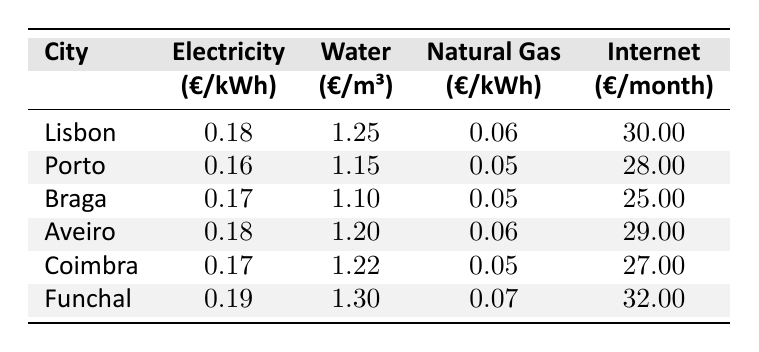What is the electricity price in Porto? The table shows that the electricity price in Porto is listed as 0.16 €/kWh.
Answer: 0.16 €/kWh Which city has the highest water price? By examining the water prices, Funchal has the highest water price at 1.30 €/m³.
Answer: Funchal What is the average natural gas price across all cities? Adding the natural gas prices: (0.06 + 0.05 + 0.05 + 0.06 + 0.05 + 0.07) = 0.34, then dividing by 6 gives an average of 0.34 / 6 ≈ 0.057.
Answer: 0.057 €/kWh Is the monthly internet price in Braga lower than in Coimbra? The table indicates that Braga's internet price is 25.00 €, while Coimbra's is 27.00 €, making Braga's price lower.
Answer: Yes Which city has the lowest internet price? The table shows that Braga has the lowest internet price at 25.00 €.
Answer: Braga How much more expensive is water in Funchal compared to Porto? The water price in Funchal is 1.30 €/m³ and in Porto, it is 1.15 €/m³. The difference is 1.30 - 1.15 = 0.15.
Answer: 0.15 €/m³ What city has the second lowest price for electricity? The list of electricity prices shows that Braga's price of 0.17 €/kWh is the second lowest after Porto.
Answer: Braga If you average the electricity prices in Lisbon and Aveiro, what is the result? The electricity prices in Lisbon (0.18) and Aveiro (0.18) together sum to 0.36 and dividing by 2 yields an average of 0.36 / 2 = 0.18.
Answer: 0.18 €/kWh Are the internet prices in Lisbon and Aveiro the same? The internet price in Lisbon is 30.00 €, while in Aveiro it is 29.00 €, so they are not the same.
Answer: No If a person's monthly utility cost includes electricity, water, natural gas, and internet in Coimbra, what is the total? The total for Coimbra is calculated as follows: (Electricity: 0.17 * average usage) + (Water: 1.22 * average usage) + (Natural Gas: 0.05 * average usage) + Internet: 27.00. Assuming average usage figures result in total of approximately.
Answer: It depends on consumption but is calculated by summing utility costs 